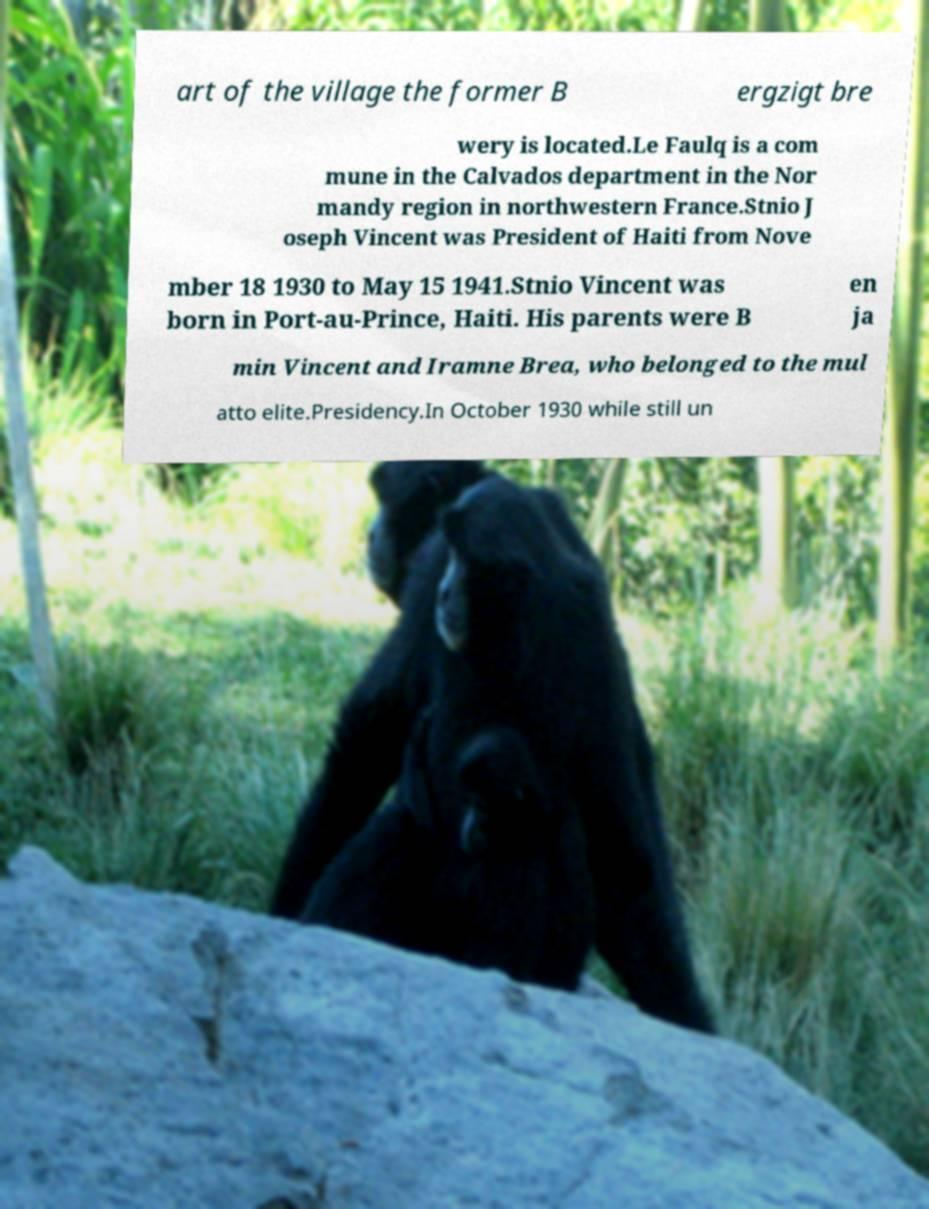Please read and relay the text visible in this image. What does it say? art of the village the former B ergzigt bre wery is located.Le Faulq is a com mune in the Calvados department in the Nor mandy region in northwestern France.Stnio J oseph Vincent was President of Haiti from Nove mber 18 1930 to May 15 1941.Stnio Vincent was born in Port-au-Prince, Haiti. His parents were B en ja min Vincent and Iramne Brea, who belonged to the mul atto elite.Presidency.In October 1930 while still un 